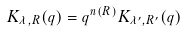Convert formula to latex. <formula><loc_0><loc_0><loc_500><loc_500>K _ { \lambda , R } ( q ) = q ^ { n ( R ) } K _ { \lambda ^ { \prime } , R ^ { \prime } } ( q )</formula> 